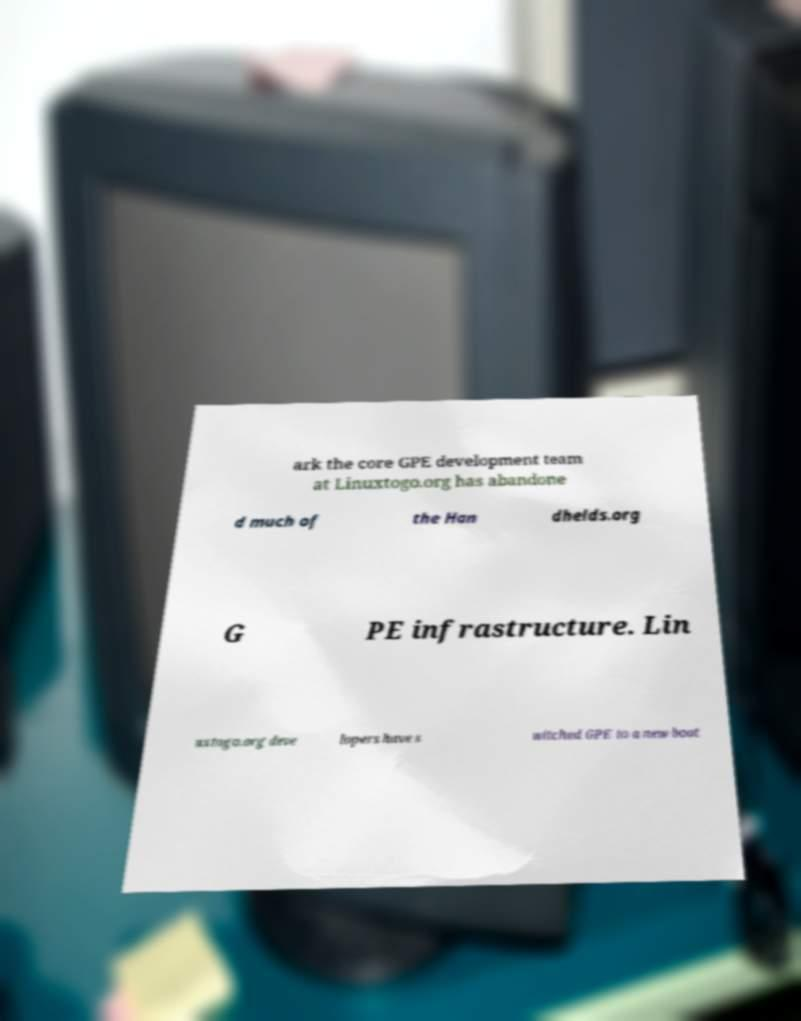There's text embedded in this image that I need extracted. Can you transcribe it verbatim? ark the core GPE development team at Linuxtogo.org has abandone d much of the Han dhelds.org G PE infrastructure. Lin uxtogo.org deve lopers have s witched GPE to a new boot 